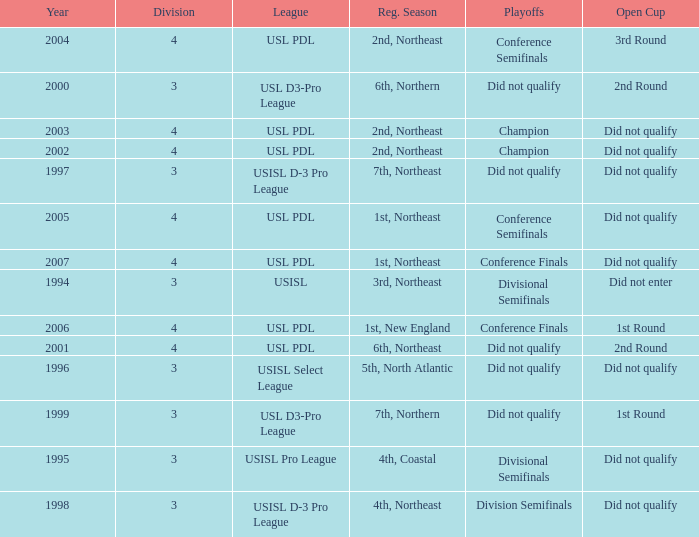Mame the reg season for 2001 6th, Northeast. 